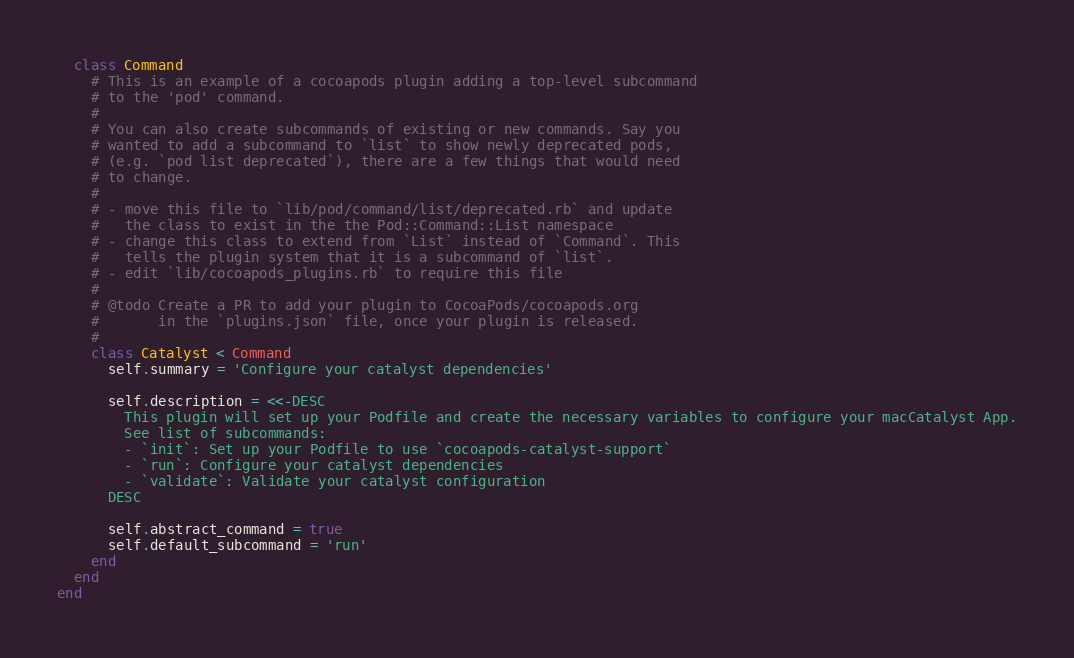<code> <loc_0><loc_0><loc_500><loc_500><_Ruby_>  class Command
    # This is an example of a cocoapods plugin adding a top-level subcommand
    # to the 'pod' command.
    #
    # You can also create subcommands of existing or new commands. Say you
    # wanted to add a subcommand to `list` to show newly deprecated pods,
    # (e.g. `pod list deprecated`), there are a few things that would need
    # to change.
    #
    # - move this file to `lib/pod/command/list/deprecated.rb` and update
    #   the class to exist in the the Pod::Command::List namespace
    # - change this class to extend from `List` instead of `Command`. This
    #   tells the plugin system that it is a subcommand of `list`.
    # - edit `lib/cocoapods_plugins.rb` to require this file
    #
    # @todo Create a PR to add your plugin to CocoaPods/cocoapods.org
    #       in the `plugins.json` file, once your plugin is released.
    #
    class Catalyst < Command
      self.summary = 'Configure your catalyst dependencies'

      self.description = <<-DESC
        This plugin will set up your Podfile and create the necessary variables to configure your macCatalyst App.
        See list of subcommands:
        - `init`: Set up your Podfile to use `cocoapods-catalyst-support`
        - `run`: Configure your catalyst dependencies
        - `validate`: Validate your catalyst configuration
      DESC

      self.abstract_command = true
      self.default_subcommand = 'run'
    end
  end
end
</code> 